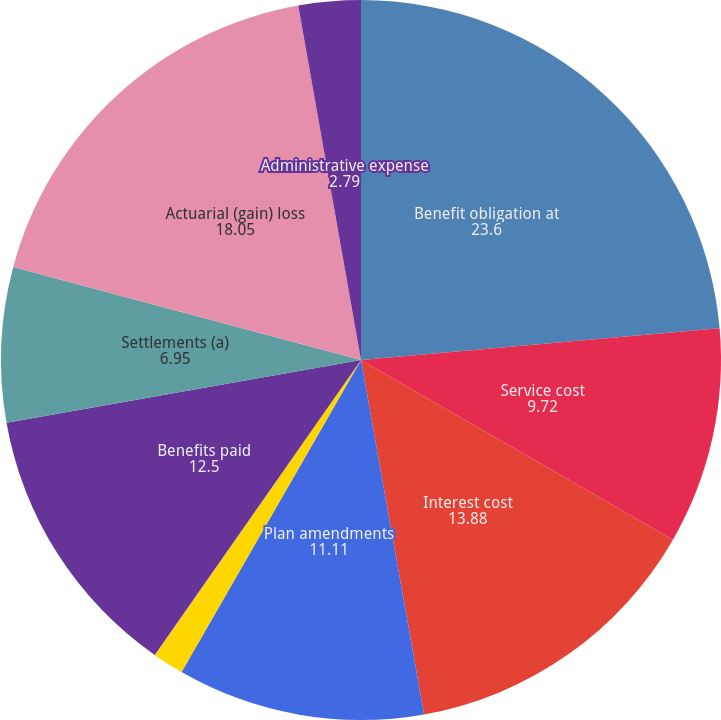Convert chart. <chart><loc_0><loc_0><loc_500><loc_500><pie_chart><fcel>Benefit obligation at<fcel>Service cost<fcel>Interest cost<fcel>Plan amendments<fcel>Curtailments<fcel>Special termination benefits<fcel>Benefits paid<fcel>Settlements (a)<fcel>Actuarial (gain) loss<fcel>Administrative expense<nl><fcel>23.6%<fcel>9.72%<fcel>13.88%<fcel>11.11%<fcel>1.4%<fcel>0.01%<fcel>12.5%<fcel>6.95%<fcel>18.05%<fcel>2.79%<nl></chart> 